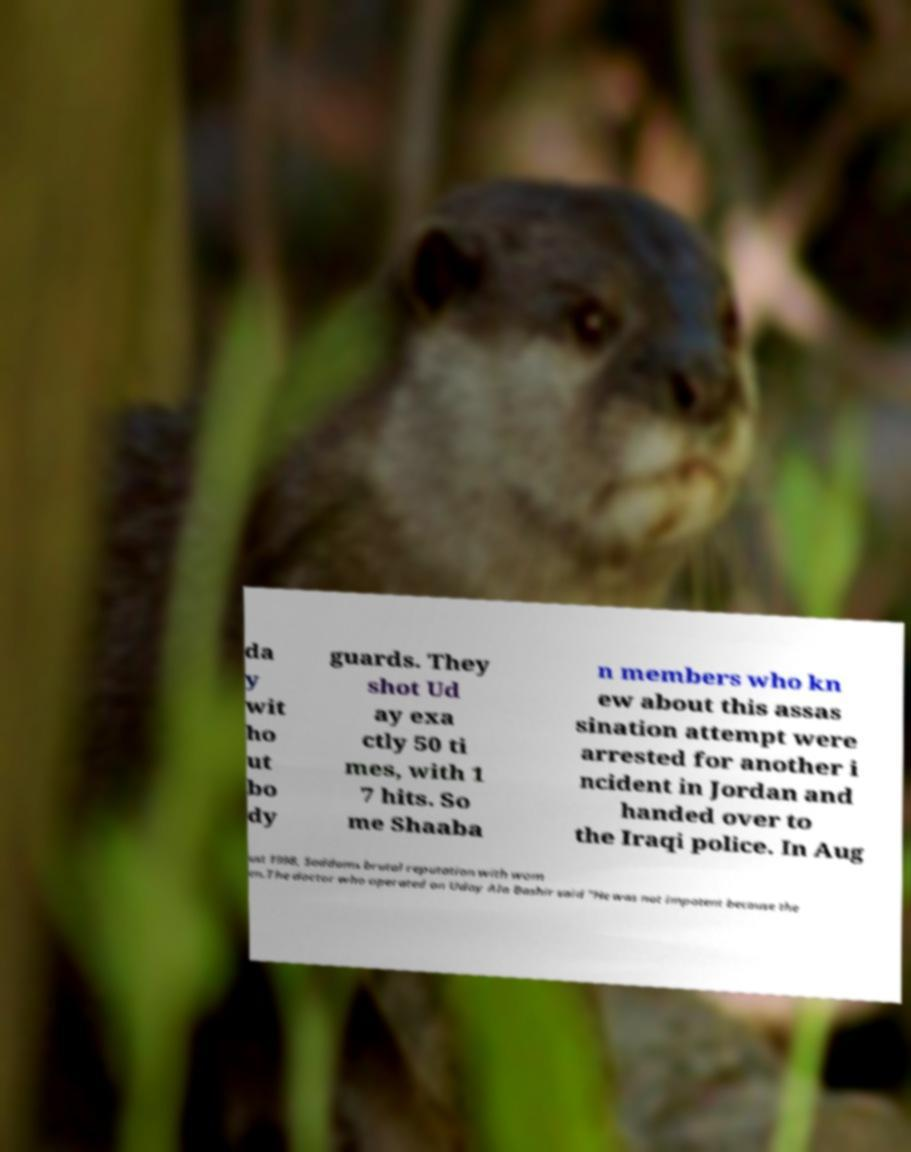What messages or text are displayed in this image? I need them in a readable, typed format. da y wit ho ut bo dy guards. They shot Ud ay exa ctly 50 ti mes, with 1 7 hits. So me Shaaba n members who kn ew about this assas sination attempt were arrested for another i ncident in Jordan and handed over to the Iraqi police. In Aug ust 1998, Saddams brutal reputation with wom en.The doctor who operated on Uday Ala Bashir said "He was not impotent because the 